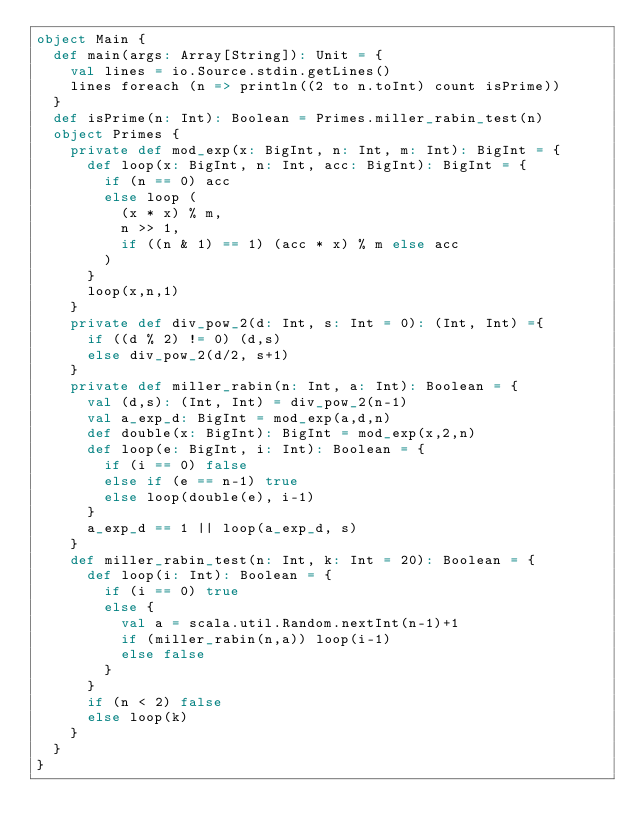<code> <loc_0><loc_0><loc_500><loc_500><_Scala_>object Main {
  def main(args: Array[String]): Unit = {
    val lines = io.Source.stdin.getLines()
    lines foreach (n => println((2 to n.toInt) count isPrime))
  }
  def isPrime(n: Int): Boolean = Primes.miller_rabin_test(n)
  object Primes {
    private def mod_exp(x: BigInt, n: Int, m: Int): BigInt = {
      def loop(x: BigInt, n: Int, acc: BigInt): BigInt = {
        if (n == 0) acc
        else loop (
          (x * x) % m,
          n >> 1,
          if ((n & 1) == 1) (acc * x) % m else acc
        )
      }
      loop(x,n,1)
    }
    private def div_pow_2(d: Int, s: Int = 0): (Int, Int) ={
      if ((d % 2) != 0) (d,s)
      else div_pow_2(d/2, s+1)
    }
    private def miller_rabin(n: Int, a: Int): Boolean = {
      val (d,s): (Int, Int) = div_pow_2(n-1)
      val a_exp_d: BigInt = mod_exp(a,d,n)
      def double(x: BigInt): BigInt = mod_exp(x,2,n)
      def loop(e: BigInt, i: Int): Boolean = {
        if (i == 0) false
        else if (e == n-1) true
        else loop(double(e), i-1)
      }
      a_exp_d == 1 || loop(a_exp_d, s)
    }
    def miller_rabin_test(n: Int, k: Int = 20): Boolean = {
      def loop(i: Int): Boolean = {
        if (i == 0) true
        else {
          val a = scala.util.Random.nextInt(n-1)+1
          if (miller_rabin(n,a)) loop(i-1)
          else false
        }
      }
      if (n < 2) false
      else loop(k)
    }
  }
}</code> 